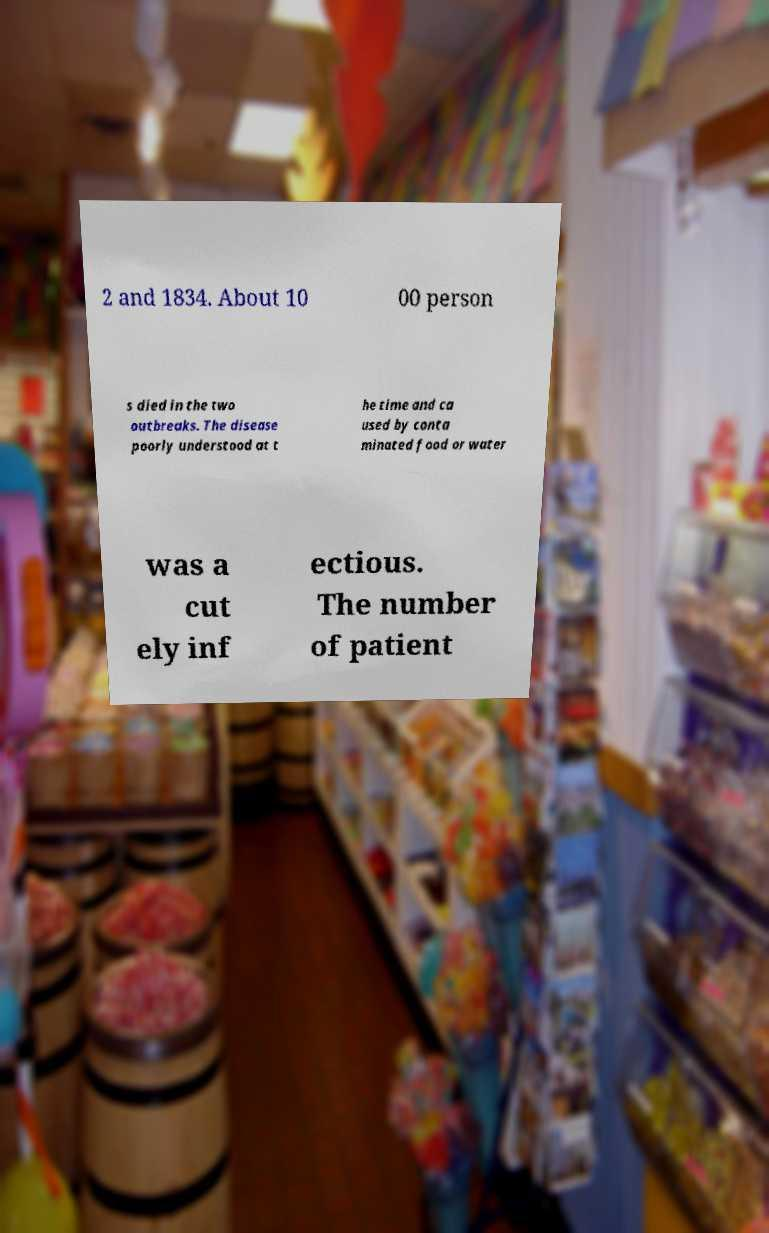Please read and relay the text visible in this image. What does it say? 2 and 1834. About 10 00 person s died in the two outbreaks. The disease poorly understood at t he time and ca used by conta minated food or water was a cut ely inf ectious. The number of patient 